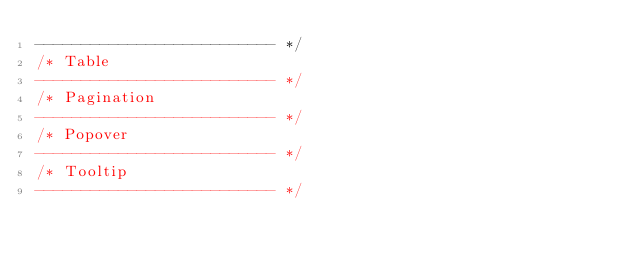<code> <loc_0><loc_0><loc_500><loc_500><_CSS_>-------------------------- */
/* Table
-------------------------- */
/* Pagination
-------------------------- */
/* Popover
-------------------------- */
/* Tooltip
-------------------------- */</code> 